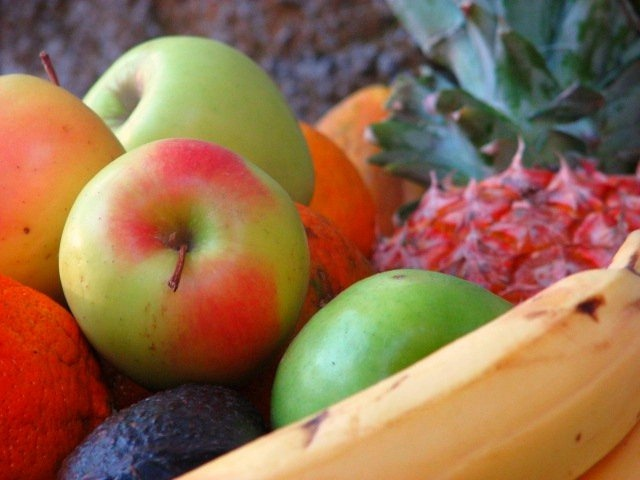Describe the objects in this image and their specific colors. I can see apple in black, olive, tan, maroon, and brown tones, banana in black, tan, and olive tones, apple in black, olive, lightgreen, and green tones, apple in black, salmon, red, and orange tones, and orange in black, maroon, and red tones in this image. 